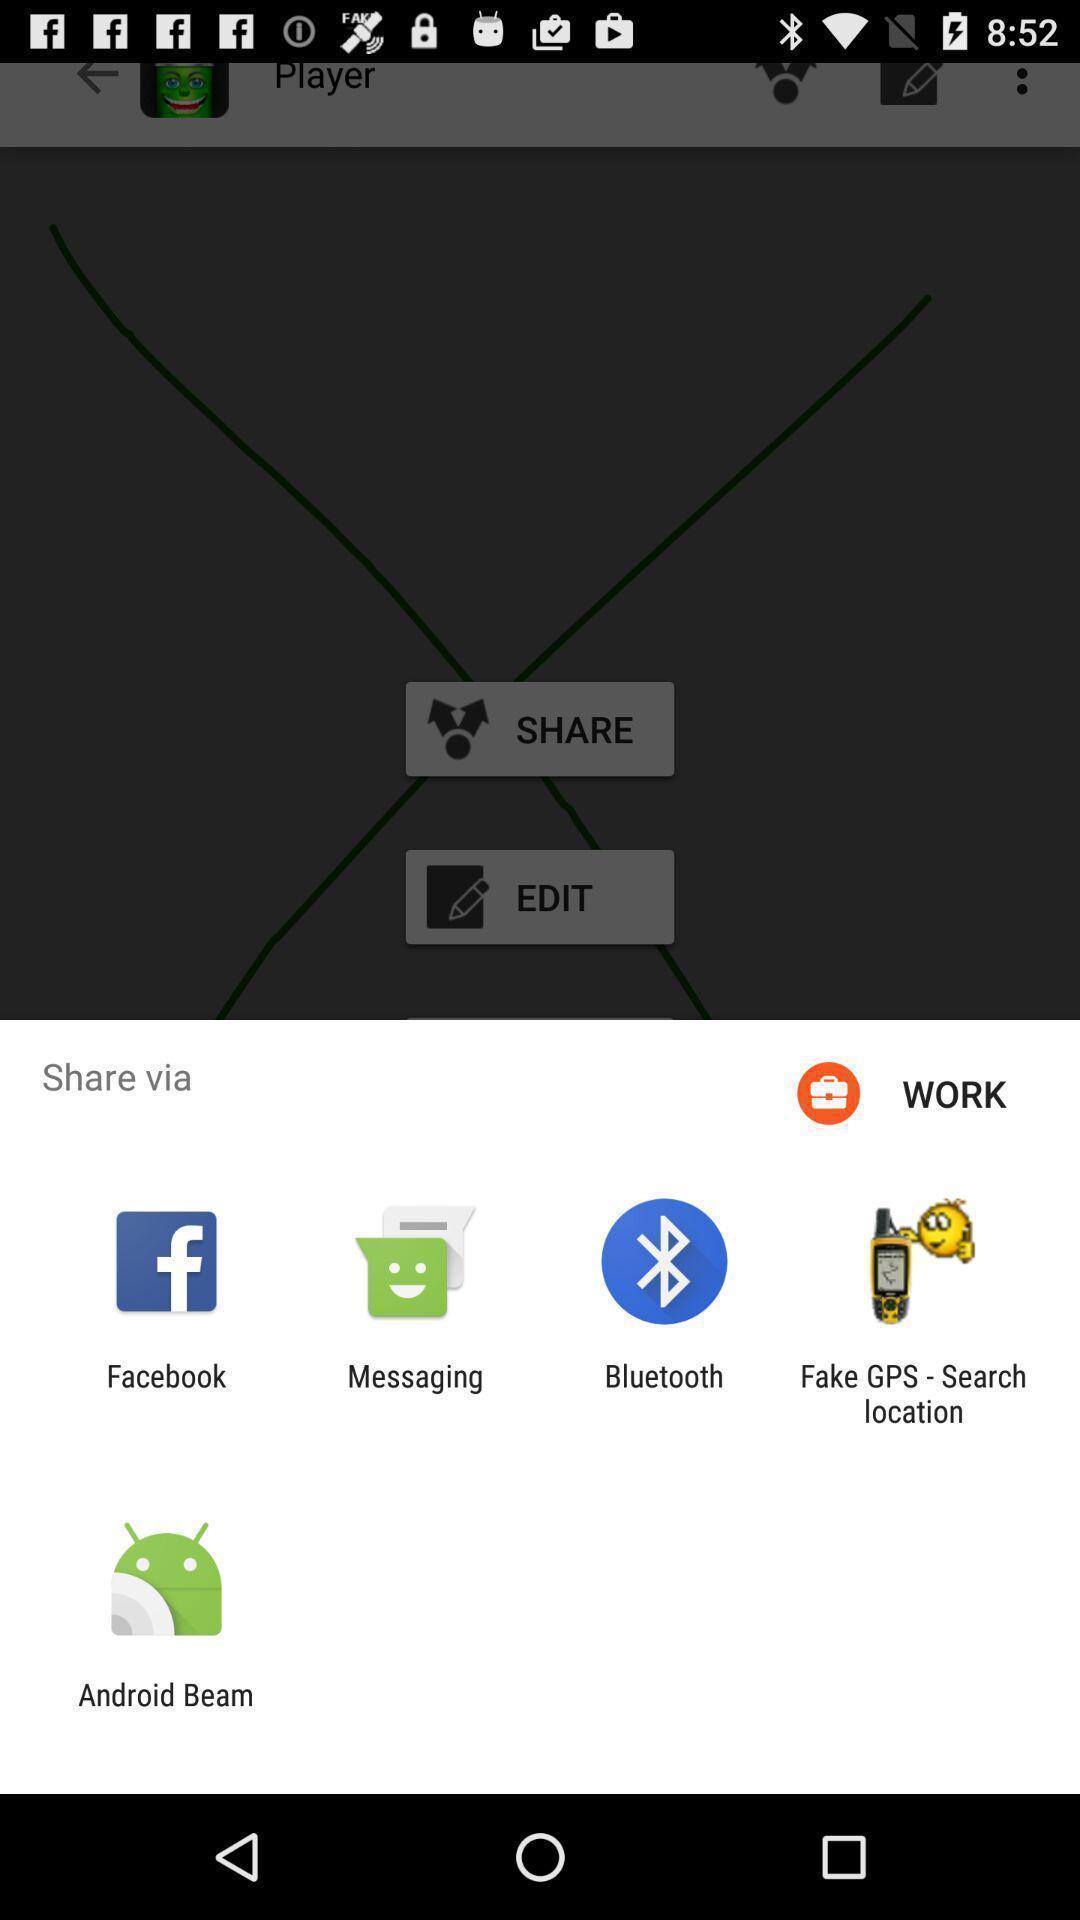Summarize the main components in this picture. Popup showing few sharing options with icons in social app. 